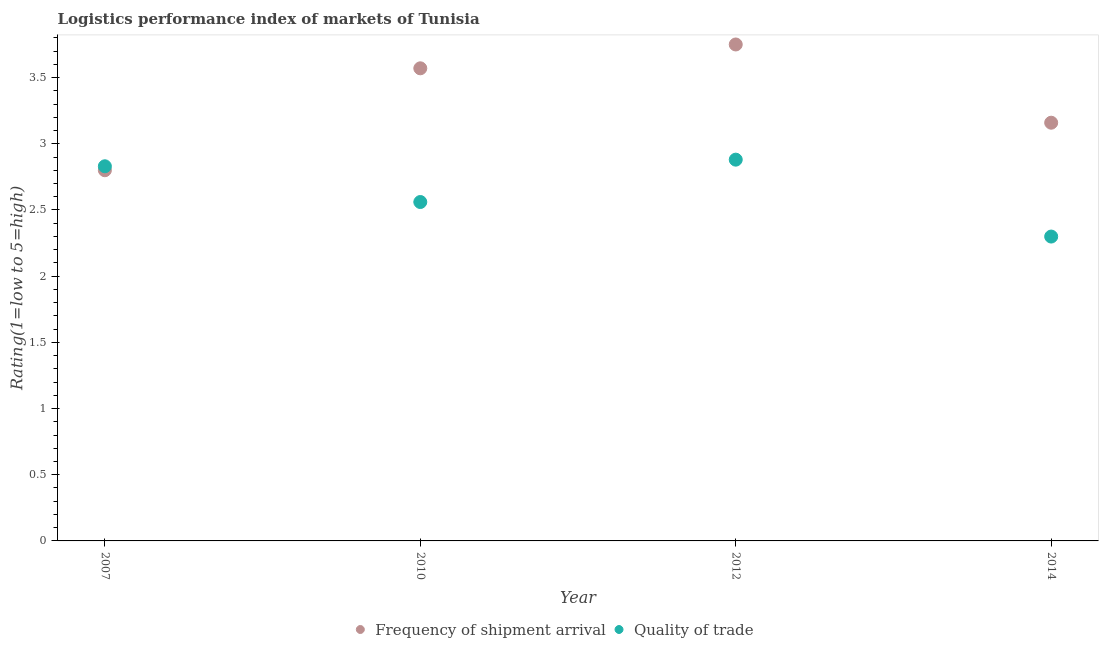Is the number of dotlines equal to the number of legend labels?
Your answer should be very brief. Yes. What is the lpi quality of trade in 2014?
Provide a succinct answer. 2.3. Across all years, what is the maximum lpi of frequency of shipment arrival?
Your answer should be compact. 3.75. Across all years, what is the minimum lpi quality of trade?
Make the answer very short. 2.3. In which year was the lpi quality of trade maximum?
Make the answer very short. 2012. What is the total lpi quality of trade in the graph?
Ensure brevity in your answer.  10.57. What is the difference between the lpi of frequency of shipment arrival in 2007 and that in 2012?
Ensure brevity in your answer.  -0.95. What is the difference between the lpi quality of trade in 2010 and the lpi of frequency of shipment arrival in 2014?
Offer a terse response. -0.6. What is the average lpi quality of trade per year?
Your response must be concise. 2.64. In the year 2014, what is the difference between the lpi of frequency of shipment arrival and lpi quality of trade?
Your answer should be compact. 0.86. What is the ratio of the lpi of frequency of shipment arrival in 2007 to that in 2012?
Provide a succinct answer. 0.75. Is the lpi quality of trade in 2012 less than that in 2014?
Make the answer very short. No. What is the difference between the highest and the second highest lpi quality of trade?
Ensure brevity in your answer.  0.05. What is the difference between the highest and the lowest lpi of frequency of shipment arrival?
Offer a very short reply. 0.95. In how many years, is the lpi of frequency of shipment arrival greater than the average lpi of frequency of shipment arrival taken over all years?
Keep it short and to the point. 2. Is the sum of the lpi of frequency of shipment arrival in 2007 and 2014 greater than the maximum lpi quality of trade across all years?
Your answer should be compact. Yes. Does the lpi quality of trade monotonically increase over the years?
Keep it short and to the point. No. Is the lpi quality of trade strictly greater than the lpi of frequency of shipment arrival over the years?
Make the answer very short. No. Is the lpi quality of trade strictly less than the lpi of frequency of shipment arrival over the years?
Provide a short and direct response. No. How many years are there in the graph?
Make the answer very short. 4. What is the difference between two consecutive major ticks on the Y-axis?
Your answer should be very brief. 0.5. Where does the legend appear in the graph?
Give a very brief answer. Bottom center. What is the title of the graph?
Offer a terse response. Logistics performance index of markets of Tunisia. Does "Male labor force" appear as one of the legend labels in the graph?
Provide a short and direct response. No. What is the label or title of the Y-axis?
Your answer should be very brief. Rating(1=low to 5=high). What is the Rating(1=low to 5=high) of Quality of trade in 2007?
Make the answer very short. 2.83. What is the Rating(1=low to 5=high) in Frequency of shipment arrival in 2010?
Provide a succinct answer. 3.57. What is the Rating(1=low to 5=high) of Quality of trade in 2010?
Your answer should be very brief. 2.56. What is the Rating(1=low to 5=high) in Frequency of shipment arrival in 2012?
Make the answer very short. 3.75. What is the Rating(1=low to 5=high) of Quality of trade in 2012?
Provide a succinct answer. 2.88. What is the Rating(1=low to 5=high) in Frequency of shipment arrival in 2014?
Offer a very short reply. 3.16. What is the Rating(1=low to 5=high) in Quality of trade in 2014?
Provide a succinct answer. 2.3. Across all years, what is the maximum Rating(1=low to 5=high) in Frequency of shipment arrival?
Your answer should be very brief. 3.75. Across all years, what is the maximum Rating(1=low to 5=high) of Quality of trade?
Your answer should be compact. 2.88. Across all years, what is the minimum Rating(1=low to 5=high) in Frequency of shipment arrival?
Your response must be concise. 2.8. Across all years, what is the minimum Rating(1=low to 5=high) in Quality of trade?
Ensure brevity in your answer.  2.3. What is the total Rating(1=low to 5=high) in Frequency of shipment arrival in the graph?
Your answer should be compact. 13.28. What is the total Rating(1=low to 5=high) in Quality of trade in the graph?
Provide a short and direct response. 10.57. What is the difference between the Rating(1=low to 5=high) of Frequency of shipment arrival in 2007 and that in 2010?
Your answer should be compact. -0.77. What is the difference between the Rating(1=low to 5=high) in Quality of trade in 2007 and that in 2010?
Your response must be concise. 0.27. What is the difference between the Rating(1=low to 5=high) in Frequency of shipment arrival in 2007 and that in 2012?
Your answer should be very brief. -0.95. What is the difference between the Rating(1=low to 5=high) in Quality of trade in 2007 and that in 2012?
Make the answer very short. -0.05. What is the difference between the Rating(1=low to 5=high) in Frequency of shipment arrival in 2007 and that in 2014?
Your answer should be very brief. -0.36. What is the difference between the Rating(1=low to 5=high) in Quality of trade in 2007 and that in 2014?
Ensure brevity in your answer.  0.53. What is the difference between the Rating(1=low to 5=high) of Frequency of shipment arrival in 2010 and that in 2012?
Give a very brief answer. -0.18. What is the difference between the Rating(1=low to 5=high) in Quality of trade in 2010 and that in 2012?
Keep it short and to the point. -0.32. What is the difference between the Rating(1=low to 5=high) in Frequency of shipment arrival in 2010 and that in 2014?
Keep it short and to the point. 0.41. What is the difference between the Rating(1=low to 5=high) of Quality of trade in 2010 and that in 2014?
Ensure brevity in your answer.  0.26. What is the difference between the Rating(1=low to 5=high) in Frequency of shipment arrival in 2012 and that in 2014?
Provide a succinct answer. 0.59. What is the difference between the Rating(1=low to 5=high) of Quality of trade in 2012 and that in 2014?
Provide a short and direct response. 0.58. What is the difference between the Rating(1=low to 5=high) in Frequency of shipment arrival in 2007 and the Rating(1=low to 5=high) in Quality of trade in 2010?
Offer a terse response. 0.24. What is the difference between the Rating(1=low to 5=high) in Frequency of shipment arrival in 2007 and the Rating(1=low to 5=high) in Quality of trade in 2012?
Provide a succinct answer. -0.08. What is the difference between the Rating(1=low to 5=high) of Frequency of shipment arrival in 2007 and the Rating(1=low to 5=high) of Quality of trade in 2014?
Ensure brevity in your answer.  0.5. What is the difference between the Rating(1=low to 5=high) in Frequency of shipment arrival in 2010 and the Rating(1=low to 5=high) in Quality of trade in 2012?
Your answer should be very brief. 0.69. What is the difference between the Rating(1=low to 5=high) of Frequency of shipment arrival in 2010 and the Rating(1=low to 5=high) of Quality of trade in 2014?
Your answer should be compact. 1.27. What is the difference between the Rating(1=low to 5=high) in Frequency of shipment arrival in 2012 and the Rating(1=low to 5=high) in Quality of trade in 2014?
Provide a short and direct response. 1.45. What is the average Rating(1=low to 5=high) in Frequency of shipment arrival per year?
Your answer should be very brief. 3.32. What is the average Rating(1=low to 5=high) in Quality of trade per year?
Your answer should be compact. 2.64. In the year 2007, what is the difference between the Rating(1=low to 5=high) of Frequency of shipment arrival and Rating(1=low to 5=high) of Quality of trade?
Your answer should be very brief. -0.03. In the year 2012, what is the difference between the Rating(1=low to 5=high) in Frequency of shipment arrival and Rating(1=low to 5=high) in Quality of trade?
Your answer should be very brief. 0.87. In the year 2014, what is the difference between the Rating(1=low to 5=high) in Frequency of shipment arrival and Rating(1=low to 5=high) in Quality of trade?
Your answer should be very brief. 0.86. What is the ratio of the Rating(1=low to 5=high) in Frequency of shipment arrival in 2007 to that in 2010?
Provide a short and direct response. 0.78. What is the ratio of the Rating(1=low to 5=high) of Quality of trade in 2007 to that in 2010?
Your answer should be compact. 1.11. What is the ratio of the Rating(1=low to 5=high) of Frequency of shipment arrival in 2007 to that in 2012?
Make the answer very short. 0.75. What is the ratio of the Rating(1=low to 5=high) of Quality of trade in 2007 to that in 2012?
Provide a succinct answer. 0.98. What is the ratio of the Rating(1=low to 5=high) of Frequency of shipment arrival in 2007 to that in 2014?
Offer a very short reply. 0.89. What is the ratio of the Rating(1=low to 5=high) in Quality of trade in 2007 to that in 2014?
Give a very brief answer. 1.23. What is the ratio of the Rating(1=low to 5=high) of Quality of trade in 2010 to that in 2012?
Offer a terse response. 0.89. What is the ratio of the Rating(1=low to 5=high) of Frequency of shipment arrival in 2010 to that in 2014?
Offer a very short reply. 1.13. What is the ratio of the Rating(1=low to 5=high) of Quality of trade in 2010 to that in 2014?
Offer a very short reply. 1.11. What is the ratio of the Rating(1=low to 5=high) in Frequency of shipment arrival in 2012 to that in 2014?
Provide a succinct answer. 1.19. What is the ratio of the Rating(1=low to 5=high) of Quality of trade in 2012 to that in 2014?
Your answer should be very brief. 1.25. What is the difference between the highest and the second highest Rating(1=low to 5=high) of Frequency of shipment arrival?
Provide a short and direct response. 0.18. What is the difference between the highest and the second highest Rating(1=low to 5=high) of Quality of trade?
Your answer should be compact. 0.05. What is the difference between the highest and the lowest Rating(1=low to 5=high) in Frequency of shipment arrival?
Give a very brief answer. 0.95. What is the difference between the highest and the lowest Rating(1=low to 5=high) in Quality of trade?
Provide a succinct answer. 0.58. 